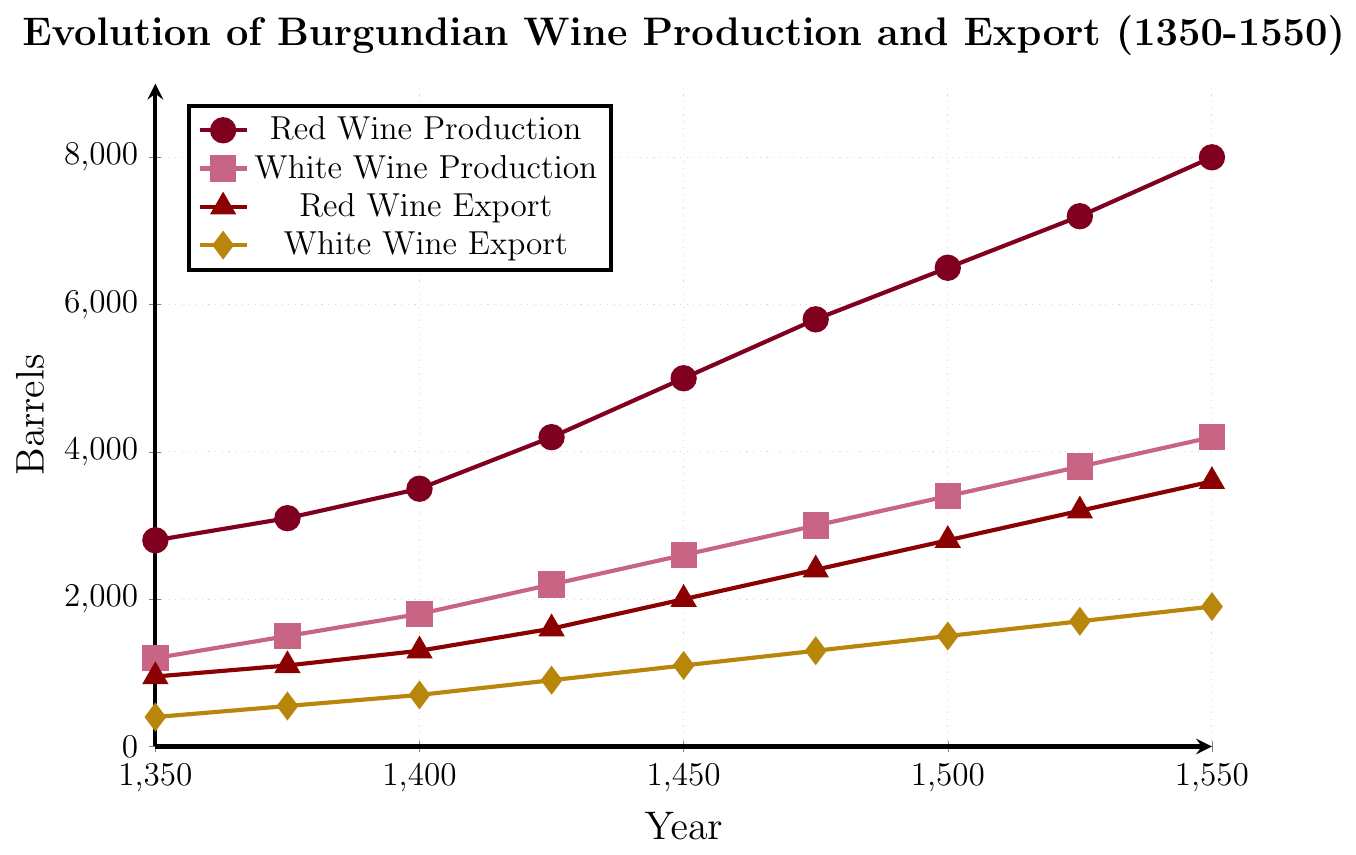what is the difference in red wine production between 1350 and 1550? To find the difference in red wine production between 1350 and 1550, we subtract the production in 1350 from the production in 1550: 8000 barrels - 2800 barrels = 5200 barrels
Answer: 5200 barrels What trend do you observe in the production of white wine from 1350 to 1550? The production of white wine shows a steady increase over the years, starting at 1200 barrels in 1350 and reaching 4200 barrels by 1550
Answer: Increasing trend Which year had the highest export volume of red wine? By examining the red wine export data points, the highest export volume is in the year 1550 with 3600 barrels
Answer: 1550 How much did the white wine export volume increase from 1375 to 1525? The white wine export volume in 1375 was 550 barrels and in 1525, it was 1700 barrels. The increase is calculated as 1700 barrels - 550 barrels = 1150 barrels
Answer: 1150 barrels Between which years did red wine production see the most significant increase? The largest increase in red wine production can be observed between 1425 and 1450, where production jumped from 4200 barrels to 5000 barrels, an increase of 800 barrels
Answer: 1425 to 1450 Compare the export volumes of white wine and red wine in the year 1500. In 1500, the red wine export volume was 2800 barrels and the white wine export volume was 1500 barrels. The red wine export volume is greater than the white wine export volume
Answer: Red wine export was greater What is the average production of red wine throughout the recorded years? To find the average, sum up the red wine production values and divide by the number of data points: (2800 + 3100 + 3500 + 4200 + 5000 + 5800 + 6500 + 7200 + 8000) / 9 = 5122.22 barrels
Answer: 5122.22 barrels Between the years 1400 and 1450, did white wine production or export grow more, and by how much? White wine production in 1400 was 1800 barrels and in 1450 it was 2600 barrels, an increase of 800 barrels. White wine export in 1400 was 700 barrels and in 1450 it was 1100 barrels, an increase of 400 barrels. Production grew more by 400 barrels
Answer: Production by 400 barrels 